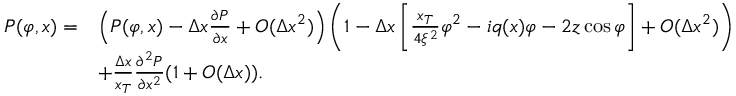<formula> <loc_0><loc_0><loc_500><loc_500>\begin{array} { r l } { P ( \varphi , x ) = } & { \left ( P ( \varphi , x ) - \Delta x \frac { \partial P } { \partial x } + O ( \Delta x ^ { 2 } ) \right ) \left ( 1 - \Delta x \left [ \frac { x _ { T } } { 4 \xi ^ { 2 } } \varphi ^ { 2 } - i q ( x ) \varphi - 2 z \cos \varphi \right ] + O ( \Delta x ^ { 2 } ) \right ) } \\ & { + \frac { \Delta x } { x _ { T } } \frac { \partial ^ { 2 } P } { \partial x ^ { 2 } } ( 1 + O ( \Delta x ) ) . } \end{array}</formula> 